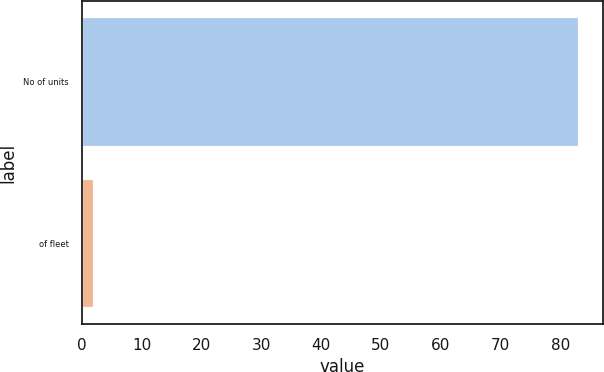Convert chart. <chart><loc_0><loc_0><loc_500><loc_500><bar_chart><fcel>No of units<fcel>of fleet<nl><fcel>83<fcel>2<nl></chart> 